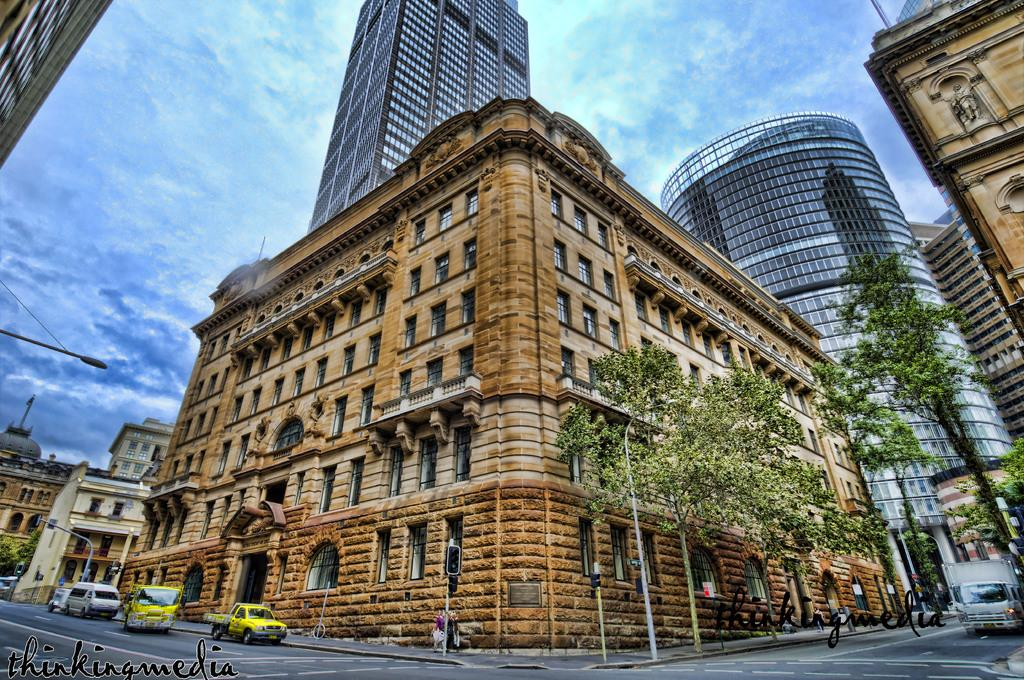What can be seen in the sky in the image? The sky is visible in the image. What type of structures are present in the image? There are buildings in the image. What other natural elements can be seen in the image? Trees are present in the image. What are the poles used for in the image? The poles are likely used for supporting wires or signs in the image. What are the vehicles doing in the image? Vehicles are on the road in the image, suggesting they are in motion or parked. What type of imperfections are present in the image? There are watermarks in the image. Where is the light pole located in the image? The light pole is on the left side of the image. Can you see a spy observing the scene from a nearby rooftop in the image? There is no indication of a spy or any person on a rooftop in the image. What type of goat can be seen grazing near the trees in the image? There are no goats present in the image; it features buildings, trees, poles, vehicles, and a light pole. What is the zinc content of the watermarks in the image? The watermarks in the image are not physical substances, so it is not possible to determine their zinc content. 